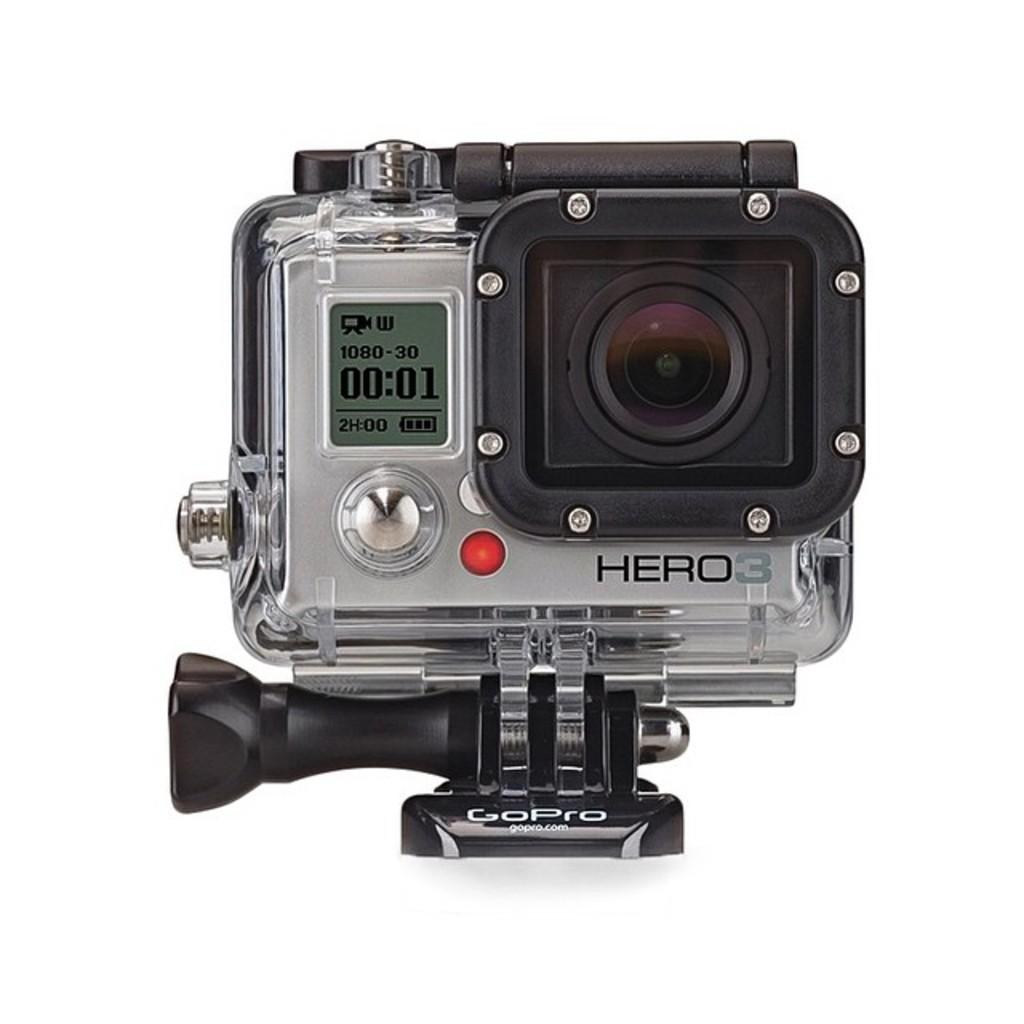What is the main subject of the image? The main subject of the image is a camera. Where is the camera located in the image? The camera is in the middle of the image. What color is the background of the image? The background of the image is white. How many cherries are on top of the camera in the image? There are no cherries present in the image, as the main subject is a camera and the background is white. 